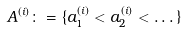Convert formula to latex. <formula><loc_0><loc_0><loc_500><loc_500>A ^ { ( i ) } \colon = \{ a _ { 1 } ^ { ( i ) } < a _ { 2 } ^ { ( i ) } < \dots \}</formula> 